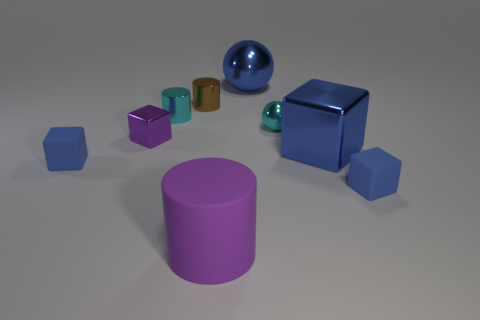What is the color of the big metallic thing that is the same shape as the tiny purple object?
Ensure brevity in your answer.  Blue. Do the matte block that is to the right of the large purple thing and the large metallic sphere have the same color?
Offer a terse response. Yes. How many large blue metallic things are there?
Your response must be concise. 2. Do the cyan object that is right of the tiny brown metallic object and the big purple cylinder have the same material?
Make the answer very short. No. There is a matte object that is right of the cylinder that is in front of the large metal cube; how many large blue shiny blocks are on the right side of it?
Ensure brevity in your answer.  0. What is the size of the cyan metallic cylinder?
Your response must be concise. Small. Does the big matte thing have the same color as the large ball?
Make the answer very short. No. How big is the blue object that is left of the blue sphere?
Keep it short and to the point. Small. Does the matte block to the right of the blue shiny cube have the same color as the metal block that is on the left side of the big purple matte cylinder?
Ensure brevity in your answer.  No. How many other things are there of the same shape as the purple shiny object?
Offer a terse response. 3. 